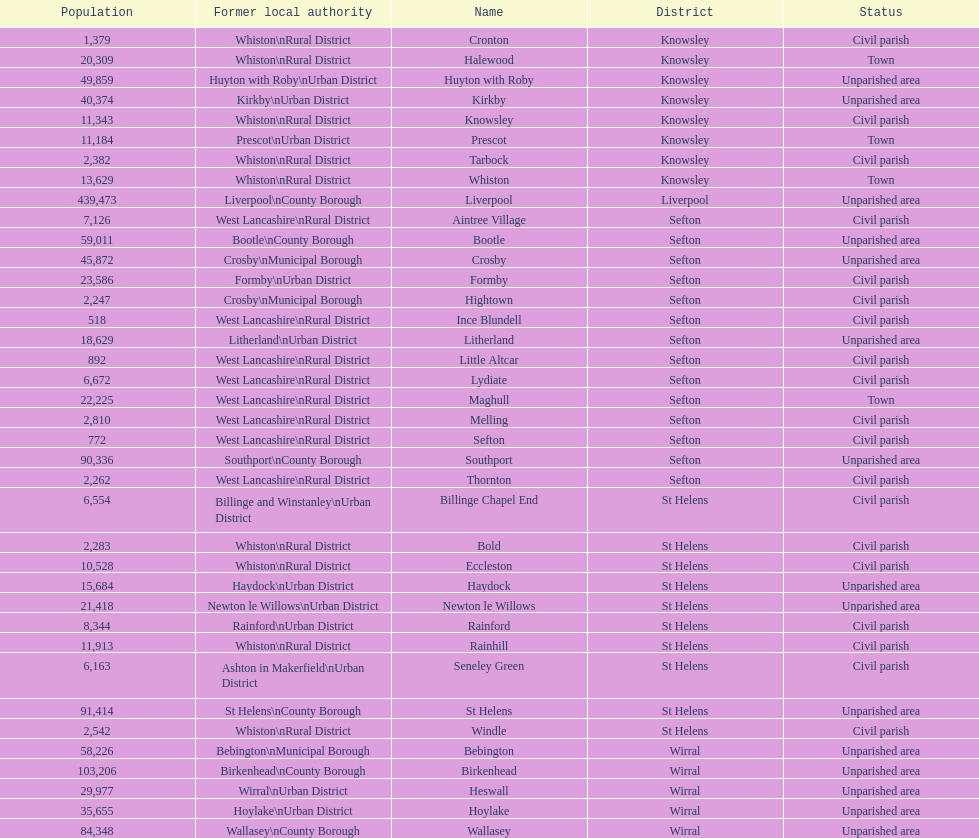Which is a civil parish, aintree village or maghull? Aintree Village. 